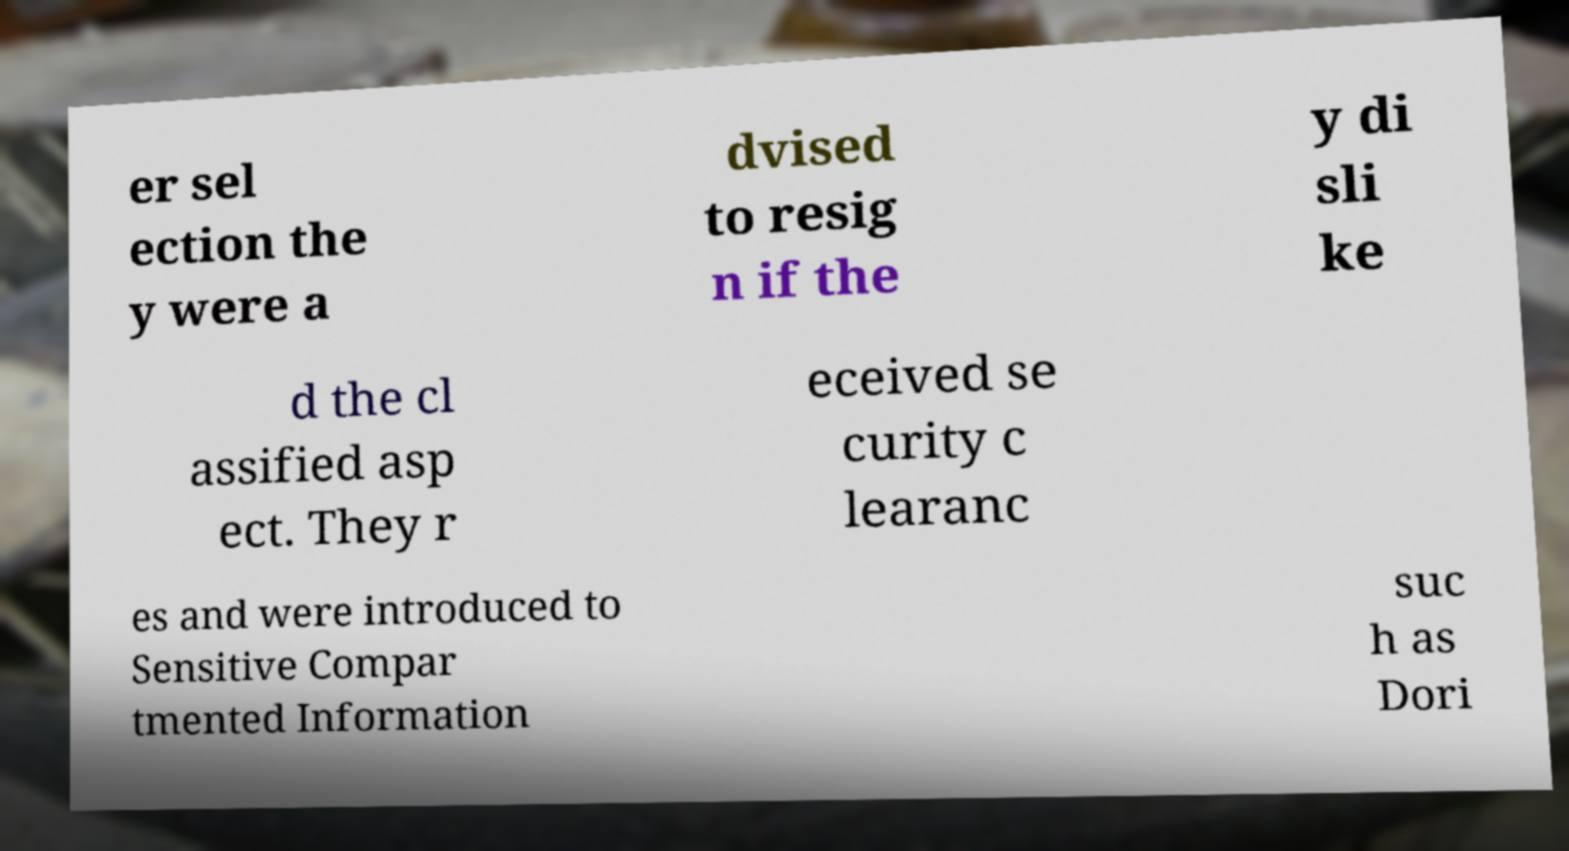For documentation purposes, I need the text within this image transcribed. Could you provide that? er sel ection the y were a dvised to resig n if the y di sli ke d the cl assified asp ect. They r eceived se curity c learanc es and were introduced to Sensitive Compar tmented Information suc h as Dori 